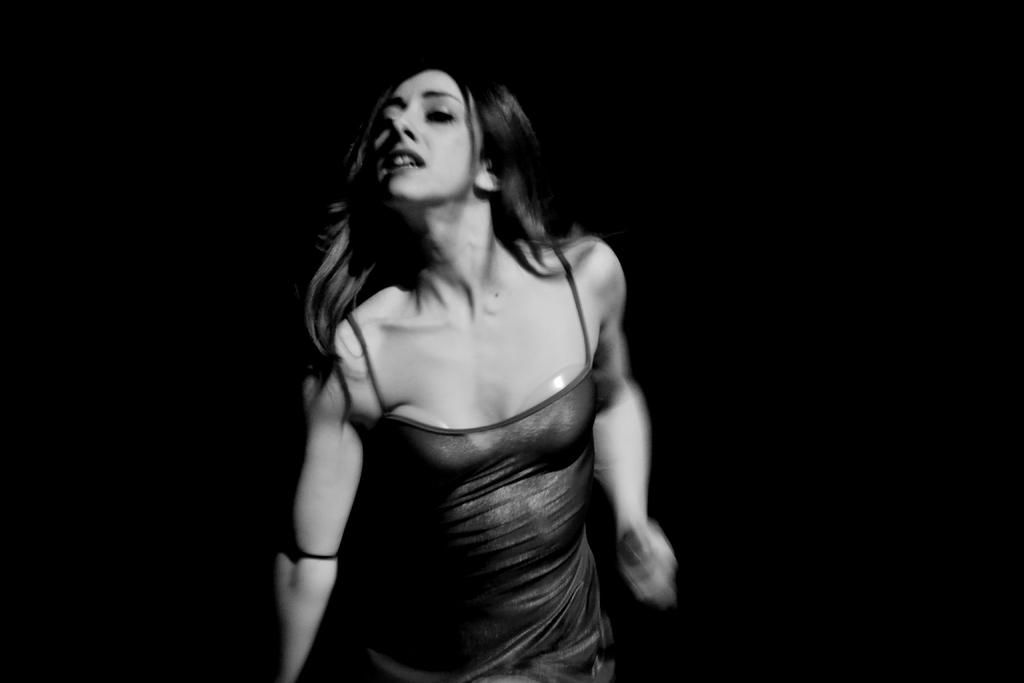Who is the main subject in the image? There is a woman in the image. What can be observed about the background of the image? The background of the image is dark. What type of heat source is visible in the image? There is no heat source visible in the image. What is the woman's occupation in the image? The provided facts do not mention the woman's occupation, so it cannot be determined from the image. 